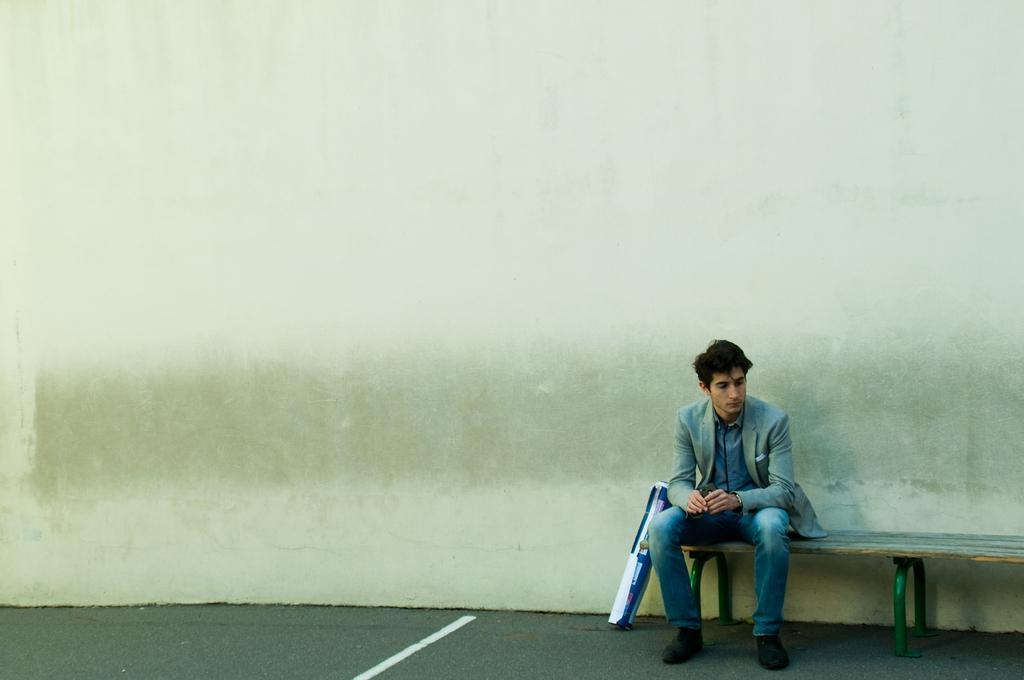Who or what is present in the image? There is a person in the image. What is the person doing in the image? The person is sitting on a bench. Are there any snails involved in a fight in the image? There are no snails or fights present in the image; it features a person sitting on a bench. 